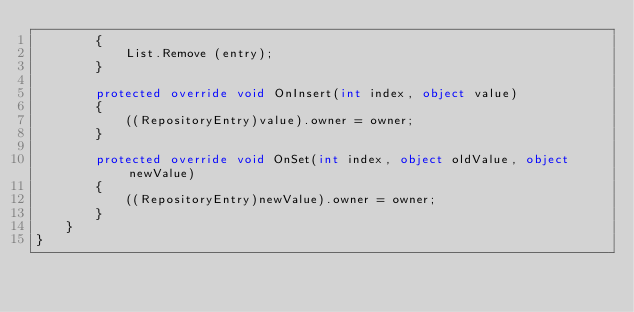Convert code to text. <code><loc_0><loc_0><loc_500><loc_500><_C#_>		{
			List.Remove (entry);
		}
		
		protected override void OnInsert(int index, object value)
		{
			((RepositoryEntry)value).owner = owner;
		}
		
		protected override void OnSet(int index, object oldValue, object newValue)
		{
			((RepositoryEntry)newValue).owner = owner;
		}
	}
}
</code> 